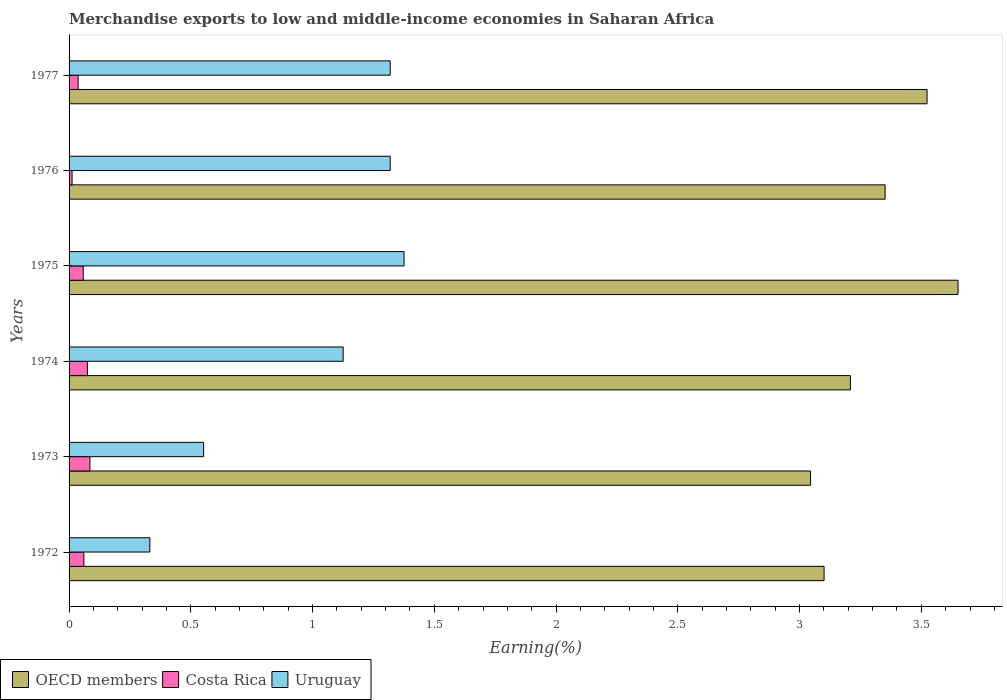How many different coloured bars are there?
Give a very brief answer. 3. What is the label of the 3rd group of bars from the top?
Offer a very short reply. 1975. What is the percentage of amount earned from merchandise exports in Costa Rica in 1975?
Your response must be concise. 0.06. Across all years, what is the maximum percentage of amount earned from merchandise exports in Costa Rica?
Your response must be concise. 0.09. Across all years, what is the minimum percentage of amount earned from merchandise exports in Costa Rica?
Your answer should be very brief. 0.01. In which year was the percentage of amount earned from merchandise exports in OECD members maximum?
Your response must be concise. 1975. In which year was the percentage of amount earned from merchandise exports in OECD members minimum?
Offer a very short reply. 1973. What is the total percentage of amount earned from merchandise exports in Costa Rica in the graph?
Your response must be concise. 0.33. What is the difference between the percentage of amount earned from merchandise exports in Uruguay in 1972 and that in 1977?
Your response must be concise. -0.99. What is the difference between the percentage of amount earned from merchandise exports in Uruguay in 1973 and the percentage of amount earned from merchandise exports in OECD members in 1972?
Make the answer very short. -2.55. What is the average percentage of amount earned from merchandise exports in OECD members per year?
Your response must be concise. 3.31. In the year 1974, what is the difference between the percentage of amount earned from merchandise exports in OECD members and percentage of amount earned from merchandise exports in Uruguay?
Make the answer very short. 2.08. In how many years, is the percentage of amount earned from merchandise exports in Uruguay greater than 1.5 %?
Offer a very short reply. 0. What is the ratio of the percentage of amount earned from merchandise exports in OECD members in 1974 to that in 1976?
Give a very brief answer. 0.96. Is the percentage of amount earned from merchandise exports in Costa Rica in 1975 less than that in 1976?
Make the answer very short. No. What is the difference between the highest and the second highest percentage of amount earned from merchandise exports in Uruguay?
Provide a succinct answer. 0.06. What is the difference between the highest and the lowest percentage of amount earned from merchandise exports in Costa Rica?
Your response must be concise. 0.07. Is it the case that in every year, the sum of the percentage of amount earned from merchandise exports in Uruguay and percentage of amount earned from merchandise exports in OECD members is greater than the percentage of amount earned from merchandise exports in Costa Rica?
Your answer should be very brief. Yes. How many bars are there?
Offer a very short reply. 18. How many years are there in the graph?
Make the answer very short. 6. Are the values on the major ticks of X-axis written in scientific E-notation?
Provide a succinct answer. No. Where does the legend appear in the graph?
Your answer should be very brief. Bottom left. What is the title of the graph?
Offer a very short reply. Merchandise exports to low and middle-income economies in Saharan Africa. Does "Panama" appear as one of the legend labels in the graph?
Provide a succinct answer. No. What is the label or title of the X-axis?
Provide a succinct answer. Earning(%). What is the label or title of the Y-axis?
Provide a short and direct response. Years. What is the Earning(%) of OECD members in 1972?
Your answer should be compact. 3.1. What is the Earning(%) in Costa Rica in 1972?
Make the answer very short. 0.06. What is the Earning(%) of Uruguay in 1972?
Offer a terse response. 0.33. What is the Earning(%) of OECD members in 1973?
Your response must be concise. 3.05. What is the Earning(%) in Costa Rica in 1973?
Ensure brevity in your answer.  0.09. What is the Earning(%) of Uruguay in 1973?
Keep it short and to the point. 0.55. What is the Earning(%) in OECD members in 1974?
Provide a short and direct response. 3.21. What is the Earning(%) in Costa Rica in 1974?
Your answer should be compact. 0.08. What is the Earning(%) in Uruguay in 1974?
Make the answer very short. 1.13. What is the Earning(%) of OECD members in 1975?
Your answer should be very brief. 3.65. What is the Earning(%) of Costa Rica in 1975?
Provide a succinct answer. 0.06. What is the Earning(%) in Uruguay in 1975?
Your answer should be very brief. 1.38. What is the Earning(%) in OECD members in 1976?
Offer a terse response. 3.35. What is the Earning(%) of Costa Rica in 1976?
Provide a succinct answer. 0.01. What is the Earning(%) in Uruguay in 1976?
Provide a short and direct response. 1.32. What is the Earning(%) of OECD members in 1977?
Offer a terse response. 3.52. What is the Earning(%) of Costa Rica in 1977?
Offer a very short reply. 0.04. What is the Earning(%) of Uruguay in 1977?
Provide a succinct answer. 1.32. Across all years, what is the maximum Earning(%) in OECD members?
Offer a terse response. 3.65. Across all years, what is the maximum Earning(%) of Costa Rica?
Give a very brief answer. 0.09. Across all years, what is the maximum Earning(%) of Uruguay?
Offer a terse response. 1.38. Across all years, what is the minimum Earning(%) of OECD members?
Keep it short and to the point. 3.05. Across all years, what is the minimum Earning(%) in Costa Rica?
Your response must be concise. 0.01. Across all years, what is the minimum Earning(%) of Uruguay?
Make the answer very short. 0.33. What is the total Earning(%) of OECD members in the graph?
Offer a very short reply. 19.88. What is the total Earning(%) of Costa Rica in the graph?
Make the answer very short. 0.33. What is the total Earning(%) in Uruguay in the graph?
Your answer should be compact. 6.02. What is the difference between the Earning(%) in OECD members in 1972 and that in 1973?
Provide a succinct answer. 0.06. What is the difference between the Earning(%) in Costa Rica in 1972 and that in 1973?
Give a very brief answer. -0.02. What is the difference between the Earning(%) of Uruguay in 1972 and that in 1973?
Keep it short and to the point. -0.22. What is the difference between the Earning(%) of OECD members in 1972 and that in 1974?
Your answer should be compact. -0.11. What is the difference between the Earning(%) in Costa Rica in 1972 and that in 1974?
Your response must be concise. -0.01. What is the difference between the Earning(%) of Uruguay in 1972 and that in 1974?
Keep it short and to the point. -0.79. What is the difference between the Earning(%) in OECD members in 1972 and that in 1975?
Your answer should be compact. -0.55. What is the difference between the Earning(%) in Costa Rica in 1972 and that in 1975?
Make the answer very short. 0. What is the difference between the Earning(%) in Uruguay in 1972 and that in 1975?
Offer a very short reply. -1.04. What is the difference between the Earning(%) in OECD members in 1972 and that in 1976?
Offer a terse response. -0.25. What is the difference between the Earning(%) in Costa Rica in 1972 and that in 1976?
Offer a terse response. 0.05. What is the difference between the Earning(%) of Uruguay in 1972 and that in 1976?
Ensure brevity in your answer.  -0.99. What is the difference between the Earning(%) in OECD members in 1972 and that in 1977?
Your response must be concise. -0.42. What is the difference between the Earning(%) in Costa Rica in 1972 and that in 1977?
Give a very brief answer. 0.02. What is the difference between the Earning(%) of Uruguay in 1972 and that in 1977?
Offer a terse response. -0.99. What is the difference between the Earning(%) of OECD members in 1973 and that in 1974?
Ensure brevity in your answer.  -0.16. What is the difference between the Earning(%) of Costa Rica in 1973 and that in 1974?
Ensure brevity in your answer.  0.01. What is the difference between the Earning(%) in Uruguay in 1973 and that in 1974?
Offer a very short reply. -0.57. What is the difference between the Earning(%) in OECD members in 1973 and that in 1975?
Provide a short and direct response. -0.61. What is the difference between the Earning(%) of Costa Rica in 1973 and that in 1975?
Your answer should be very brief. 0.03. What is the difference between the Earning(%) in Uruguay in 1973 and that in 1975?
Give a very brief answer. -0.82. What is the difference between the Earning(%) in OECD members in 1973 and that in 1976?
Give a very brief answer. -0.31. What is the difference between the Earning(%) of Costa Rica in 1973 and that in 1976?
Keep it short and to the point. 0.07. What is the difference between the Earning(%) of Uruguay in 1973 and that in 1976?
Your answer should be compact. -0.77. What is the difference between the Earning(%) in OECD members in 1973 and that in 1977?
Your answer should be very brief. -0.48. What is the difference between the Earning(%) in Costa Rica in 1973 and that in 1977?
Give a very brief answer. 0.05. What is the difference between the Earning(%) in Uruguay in 1973 and that in 1977?
Keep it short and to the point. -0.77. What is the difference between the Earning(%) in OECD members in 1974 and that in 1975?
Provide a succinct answer. -0.44. What is the difference between the Earning(%) in Costa Rica in 1974 and that in 1975?
Ensure brevity in your answer.  0.02. What is the difference between the Earning(%) in OECD members in 1974 and that in 1976?
Your answer should be compact. -0.14. What is the difference between the Earning(%) in Costa Rica in 1974 and that in 1976?
Ensure brevity in your answer.  0.06. What is the difference between the Earning(%) of Uruguay in 1974 and that in 1976?
Keep it short and to the point. -0.19. What is the difference between the Earning(%) in OECD members in 1974 and that in 1977?
Keep it short and to the point. -0.31. What is the difference between the Earning(%) in Costa Rica in 1974 and that in 1977?
Your response must be concise. 0.04. What is the difference between the Earning(%) in Uruguay in 1974 and that in 1977?
Your response must be concise. -0.19. What is the difference between the Earning(%) of OECD members in 1975 and that in 1976?
Keep it short and to the point. 0.3. What is the difference between the Earning(%) of Costa Rica in 1975 and that in 1976?
Give a very brief answer. 0.05. What is the difference between the Earning(%) of Uruguay in 1975 and that in 1976?
Make the answer very short. 0.06. What is the difference between the Earning(%) in OECD members in 1975 and that in 1977?
Your answer should be compact. 0.13. What is the difference between the Earning(%) in Costa Rica in 1975 and that in 1977?
Your response must be concise. 0.02. What is the difference between the Earning(%) in Uruguay in 1975 and that in 1977?
Offer a terse response. 0.06. What is the difference between the Earning(%) of OECD members in 1976 and that in 1977?
Keep it short and to the point. -0.17. What is the difference between the Earning(%) of Costa Rica in 1976 and that in 1977?
Give a very brief answer. -0.02. What is the difference between the Earning(%) of Uruguay in 1976 and that in 1977?
Ensure brevity in your answer.  -0. What is the difference between the Earning(%) of OECD members in 1972 and the Earning(%) of Costa Rica in 1973?
Your response must be concise. 3.02. What is the difference between the Earning(%) in OECD members in 1972 and the Earning(%) in Uruguay in 1973?
Your response must be concise. 2.55. What is the difference between the Earning(%) in Costa Rica in 1972 and the Earning(%) in Uruguay in 1973?
Keep it short and to the point. -0.49. What is the difference between the Earning(%) in OECD members in 1972 and the Earning(%) in Costa Rica in 1974?
Offer a terse response. 3.03. What is the difference between the Earning(%) of OECD members in 1972 and the Earning(%) of Uruguay in 1974?
Your answer should be very brief. 1.98. What is the difference between the Earning(%) of Costa Rica in 1972 and the Earning(%) of Uruguay in 1974?
Provide a succinct answer. -1.06. What is the difference between the Earning(%) of OECD members in 1972 and the Earning(%) of Costa Rica in 1975?
Give a very brief answer. 3.04. What is the difference between the Earning(%) of OECD members in 1972 and the Earning(%) of Uruguay in 1975?
Your response must be concise. 1.73. What is the difference between the Earning(%) in Costa Rica in 1972 and the Earning(%) in Uruguay in 1975?
Keep it short and to the point. -1.31. What is the difference between the Earning(%) in OECD members in 1972 and the Earning(%) in Costa Rica in 1976?
Your answer should be very brief. 3.09. What is the difference between the Earning(%) of OECD members in 1972 and the Earning(%) of Uruguay in 1976?
Ensure brevity in your answer.  1.78. What is the difference between the Earning(%) of Costa Rica in 1972 and the Earning(%) of Uruguay in 1976?
Offer a terse response. -1.26. What is the difference between the Earning(%) in OECD members in 1972 and the Earning(%) in Costa Rica in 1977?
Give a very brief answer. 3.06. What is the difference between the Earning(%) of OECD members in 1972 and the Earning(%) of Uruguay in 1977?
Give a very brief answer. 1.78. What is the difference between the Earning(%) in Costa Rica in 1972 and the Earning(%) in Uruguay in 1977?
Offer a very short reply. -1.26. What is the difference between the Earning(%) in OECD members in 1973 and the Earning(%) in Costa Rica in 1974?
Your answer should be very brief. 2.97. What is the difference between the Earning(%) in OECD members in 1973 and the Earning(%) in Uruguay in 1974?
Your response must be concise. 1.92. What is the difference between the Earning(%) in Costa Rica in 1973 and the Earning(%) in Uruguay in 1974?
Offer a very short reply. -1.04. What is the difference between the Earning(%) of OECD members in 1973 and the Earning(%) of Costa Rica in 1975?
Your answer should be very brief. 2.99. What is the difference between the Earning(%) of OECD members in 1973 and the Earning(%) of Uruguay in 1975?
Your answer should be compact. 1.67. What is the difference between the Earning(%) of Costa Rica in 1973 and the Earning(%) of Uruguay in 1975?
Keep it short and to the point. -1.29. What is the difference between the Earning(%) in OECD members in 1973 and the Earning(%) in Costa Rica in 1976?
Your answer should be very brief. 3.03. What is the difference between the Earning(%) of OECD members in 1973 and the Earning(%) of Uruguay in 1976?
Your answer should be compact. 1.73. What is the difference between the Earning(%) in Costa Rica in 1973 and the Earning(%) in Uruguay in 1976?
Ensure brevity in your answer.  -1.23. What is the difference between the Earning(%) in OECD members in 1973 and the Earning(%) in Costa Rica in 1977?
Provide a short and direct response. 3.01. What is the difference between the Earning(%) of OECD members in 1973 and the Earning(%) of Uruguay in 1977?
Provide a succinct answer. 1.73. What is the difference between the Earning(%) in Costa Rica in 1973 and the Earning(%) in Uruguay in 1977?
Your response must be concise. -1.23. What is the difference between the Earning(%) of OECD members in 1974 and the Earning(%) of Costa Rica in 1975?
Your answer should be compact. 3.15. What is the difference between the Earning(%) of OECD members in 1974 and the Earning(%) of Uruguay in 1975?
Make the answer very short. 1.83. What is the difference between the Earning(%) of Costa Rica in 1974 and the Earning(%) of Uruguay in 1975?
Make the answer very short. -1.3. What is the difference between the Earning(%) in OECD members in 1974 and the Earning(%) in Costa Rica in 1976?
Keep it short and to the point. 3.2. What is the difference between the Earning(%) of OECD members in 1974 and the Earning(%) of Uruguay in 1976?
Ensure brevity in your answer.  1.89. What is the difference between the Earning(%) of Costa Rica in 1974 and the Earning(%) of Uruguay in 1976?
Ensure brevity in your answer.  -1.24. What is the difference between the Earning(%) of OECD members in 1974 and the Earning(%) of Costa Rica in 1977?
Keep it short and to the point. 3.17. What is the difference between the Earning(%) of OECD members in 1974 and the Earning(%) of Uruguay in 1977?
Ensure brevity in your answer.  1.89. What is the difference between the Earning(%) of Costa Rica in 1974 and the Earning(%) of Uruguay in 1977?
Your response must be concise. -1.24. What is the difference between the Earning(%) of OECD members in 1975 and the Earning(%) of Costa Rica in 1976?
Provide a short and direct response. 3.64. What is the difference between the Earning(%) in OECD members in 1975 and the Earning(%) in Uruguay in 1976?
Give a very brief answer. 2.33. What is the difference between the Earning(%) in Costa Rica in 1975 and the Earning(%) in Uruguay in 1976?
Your answer should be compact. -1.26. What is the difference between the Earning(%) of OECD members in 1975 and the Earning(%) of Costa Rica in 1977?
Your response must be concise. 3.61. What is the difference between the Earning(%) of OECD members in 1975 and the Earning(%) of Uruguay in 1977?
Give a very brief answer. 2.33. What is the difference between the Earning(%) of Costa Rica in 1975 and the Earning(%) of Uruguay in 1977?
Your answer should be compact. -1.26. What is the difference between the Earning(%) of OECD members in 1976 and the Earning(%) of Costa Rica in 1977?
Your answer should be very brief. 3.31. What is the difference between the Earning(%) in OECD members in 1976 and the Earning(%) in Uruguay in 1977?
Your answer should be compact. 2.03. What is the difference between the Earning(%) of Costa Rica in 1976 and the Earning(%) of Uruguay in 1977?
Give a very brief answer. -1.31. What is the average Earning(%) in OECD members per year?
Your answer should be compact. 3.31. What is the average Earning(%) of Costa Rica per year?
Offer a terse response. 0.05. What is the average Earning(%) of Uruguay per year?
Provide a short and direct response. 1. In the year 1972, what is the difference between the Earning(%) in OECD members and Earning(%) in Costa Rica?
Give a very brief answer. 3.04. In the year 1972, what is the difference between the Earning(%) of OECD members and Earning(%) of Uruguay?
Make the answer very short. 2.77. In the year 1972, what is the difference between the Earning(%) of Costa Rica and Earning(%) of Uruguay?
Your answer should be compact. -0.27. In the year 1973, what is the difference between the Earning(%) of OECD members and Earning(%) of Costa Rica?
Offer a very short reply. 2.96. In the year 1973, what is the difference between the Earning(%) of OECD members and Earning(%) of Uruguay?
Your response must be concise. 2.49. In the year 1973, what is the difference between the Earning(%) of Costa Rica and Earning(%) of Uruguay?
Keep it short and to the point. -0.47. In the year 1974, what is the difference between the Earning(%) of OECD members and Earning(%) of Costa Rica?
Your answer should be very brief. 3.13. In the year 1974, what is the difference between the Earning(%) of OECD members and Earning(%) of Uruguay?
Provide a short and direct response. 2.08. In the year 1974, what is the difference between the Earning(%) in Costa Rica and Earning(%) in Uruguay?
Offer a very short reply. -1.05. In the year 1975, what is the difference between the Earning(%) in OECD members and Earning(%) in Costa Rica?
Your answer should be compact. 3.59. In the year 1975, what is the difference between the Earning(%) of OECD members and Earning(%) of Uruguay?
Offer a very short reply. 2.28. In the year 1975, what is the difference between the Earning(%) of Costa Rica and Earning(%) of Uruguay?
Offer a terse response. -1.32. In the year 1976, what is the difference between the Earning(%) in OECD members and Earning(%) in Costa Rica?
Provide a short and direct response. 3.34. In the year 1976, what is the difference between the Earning(%) in OECD members and Earning(%) in Uruguay?
Provide a short and direct response. 2.03. In the year 1976, what is the difference between the Earning(%) of Costa Rica and Earning(%) of Uruguay?
Offer a terse response. -1.31. In the year 1977, what is the difference between the Earning(%) of OECD members and Earning(%) of Costa Rica?
Keep it short and to the point. 3.49. In the year 1977, what is the difference between the Earning(%) in OECD members and Earning(%) in Uruguay?
Make the answer very short. 2.2. In the year 1977, what is the difference between the Earning(%) in Costa Rica and Earning(%) in Uruguay?
Provide a succinct answer. -1.28. What is the ratio of the Earning(%) in OECD members in 1972 to that in 1973?
Make the answer very short. 1.02. What is the ratio of the Earning(%) of Costa Rica in 1972 to that in 1973?
Your response must be concise. 0.71. What is the ratio of the Earning(%) of Uruguay in 1972 to that in 1973?
Ensure brevity in your answer.  0.6. What is the ratio of the Earning(%) in OECD members in 1972 to that in 1974?
Offer a very short reply. 0.97. What is the ratio of the Earning(%) in Costa Rica in 1972 to that in 1974?
Your response must be concise. 0.81. What is the ratio of the Earning(%) of Uruguay in 1972 to that in 1974?
Your response must be concise. 0.29. What is the ratio of the Earning(%) of OECD members in 1972 to that in 1975?
Provide a succinct answer. 0.85. What is the ratio of the Earning(%) in Costa Rica in 1972 to that in 1975?
Your answer should be very brief. 1.04. What is the ratio of the Earning(%) in Uruguay in 1972 to that in 1975?
Ensure brevity in your answer.  0.24. What is the ratio of the Earning(%) of OECD members in 1972 to that in 1976?
Your answer should be compact. 0.93. What is the ratio of the Earning(%) of Costa Rica in 1972 to that in 1976?
Provide a succinct answer. 4.93. What is the ratio of the Earning(%) of Uruguay in 1972 to that in 1976?
Your answer should be very brief. 0.25. What is the ratio of the Earning(%) in Costa Rica in 1972 to that in 1977?
Offer a very short reply. 1.63. What is the ratio of the Earning(%) of Uruguay in 1972 to that in 1977?
Give a very brief answer. 0.25. What is the ratio of the Earning(%) of OECD members in 1973 to that in 1974?
Offer a terse response. 0.95. What is the ratio of the Earning(%) of Costa Rica in 1973 to that in 1974?
Your answer should be compact. 1.14. What is the ratio of the Earning(%) in Uruguay in 1973 to that in 1974?
Your response must be concise. 0.49. What is the ratio of the Earning(%) in OECD members in 1973 to that in 1975?
Provide a short and direct response. 0.83. What is the ratio of the Earning(%) of Costa Rica in 1973 to that in 1975?
Offer a terse response. 1.47. What is the ratio of the Earning(%) of Uruguay in 1973 to that in 1975?
Keep it short and to the point. 0.4. What is the ratio of the Earning(%) in OECD members in 1973 to that in 1976?
Keep it short and to the point. 0.91. What is the ratio of the Earning(%) in Costa Rica in 1973 to that in 1976?
Your answer should be compact. 6.96. What is the ratio of the Earning(%) in Uruguay in 1973 to that in 1976?
Provide a short and direct response. 0.42. What is the ratio of the Earning(%) in OECD members in 1973 to that in 1977?
Offer a very short reply. 0.86. What is the ratio of the Earning(%) in Costa Rica in 1973 to that in 1977?
Give a very brief answer. 2.3. What is the ratio of the Earning(%) in Uruguay in 1973 to that in 1977?
Make the answer very short. 0.42. What is the ratio of the Earning(%) in OECD members in 1974 to that in 1975?
Make the answer very short. 0.88. What is the ratio of the Earning(%) of Costa Rica in 1974 to that in 1975?
Your answer should be compact. 1.3. What is the ratio of the Earning(%) in Uruguay in 1974 to that in 1975?
Offer a very short reply. 0.82. What is the ratio of the Earning(%) of OECD members in 1974 to that in 1976?
Ensure brevity in your answer.  0.96. What is the ratio of the Earning(%) in Costa Rica in 1974 to that in 1976?
Offer a very short reply. 6.12. What is the ratio of the Earning(%) of Uruguay in 1974 to that in 1976?
Provide a succinct answer. 0.85. What is the ratio of the Earning(%) of OECD members in 1974 to that in 1977?
Provide a succinct answer. 0.91. What is the ratio of the Earning(%) of Costa Rica in 1974 to that in 1977?
Give a very brief answer. 2.03. What is the ratio of the Earning(%) in Uruguay in 1974 to that in 1977?
Provide a short and direct response. 0.85. What is the ratio of the Earning(%) in OECD members in 1975 to that in 1976?
Keep it short and to the point. 1.09. What is the ratio of the Earning(%) in Costa Rica in 1975 to that in 1976?
Give a very brief answer. 4.72. What is the ratio of the Earning(%) of Uruguay in 1975 to that in 1976?
Keep it short and to the point. 1.04. What is the ratio of the Earning(%) of OECD members in 1975 to that in 1977?
Your answer should be very brief. 1.04. What is the ratio of the Earning(%) of Costa Rica in 1975 to that in 1977?
Offer a very short reply. 1.56. What is the ratio of the Earning(%) of Uruguay in 1975 to that in 1977?
Keep it short and to the point. 1.04. What is the ratio of the Earning(%) of OECD members in 1976 to that in 1977?
Offer a terse response. 0.95. What is the ratio of the Earning(%) of Costa Rica in 1976 to that in 1977?
Provide a short and direct response. 0.33. What is the difference between the highest and the second highest Earning(%) in OECD members?
Give a very brief answer. 0.13. What is the difference between the highest and the second highest Earning(%) of Costa Rica?
Keep it short and to the point. 0.01. What is the difference between the highest and the second highest Earning(%) of Uruguay?
Keep it short and to the point. 0.06. What is the difference between the highest and the lowest Earning(%) in OECD members?
Provide a succinct answer. 0.61. What is the difference between the highest and the lowest Earning(%) in Costa Rica?
Offer a very short reply. 0.07. What is the difference between the highest and the lowest Earning(%) in Uruguay?
Your answer should be compact. 1.04. 